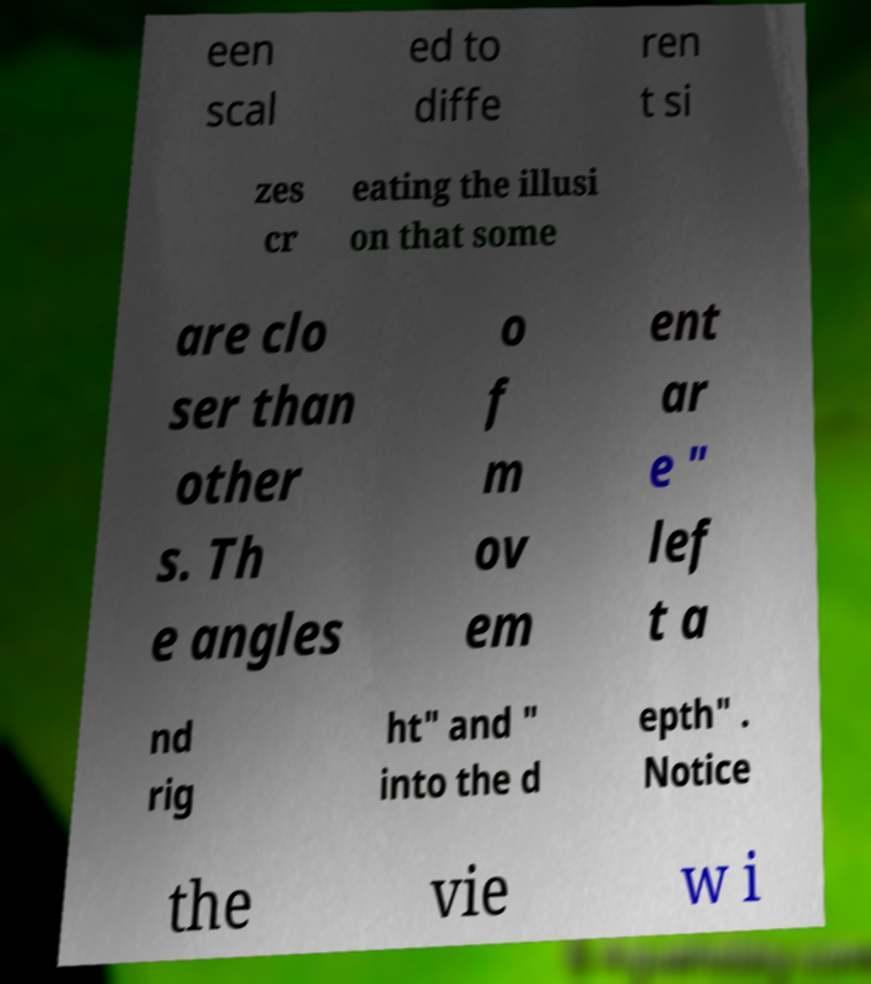Please read and relay the text visible in this image. What does it say? een scal ed to diffe ren t si zes cr eating the illusi on that some are clo ser than other s. Th e angles o f m ov em ent ar e " lef t a nd rig ht" and " into the d epth" . Notice the vie w i 